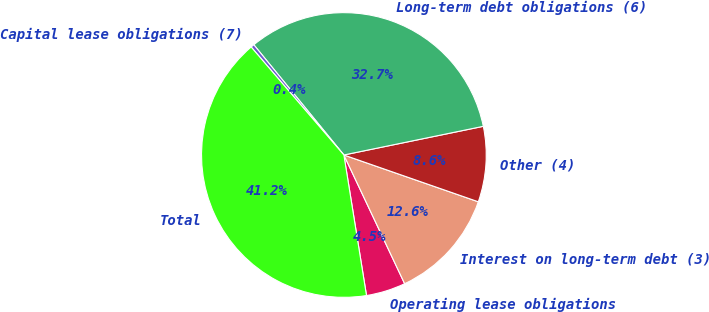Convert chart to OTSL. <chart><loc_0><loc_0><loc_500><loc_500><pie_chart><fcel>Operating lease obligations<fcel>Interest on long-term debt (3)<fcel>Other (4)<fcel>Long-term debt obligations (6)<fcel>Capital lease obligations (7)<fcel>Total<nl><fcel>4.48%<fcel>12.65%<fcel>8.56%<fcel>32.68%<fcel>0.39%<fcel>41.25%<nl></chart> 